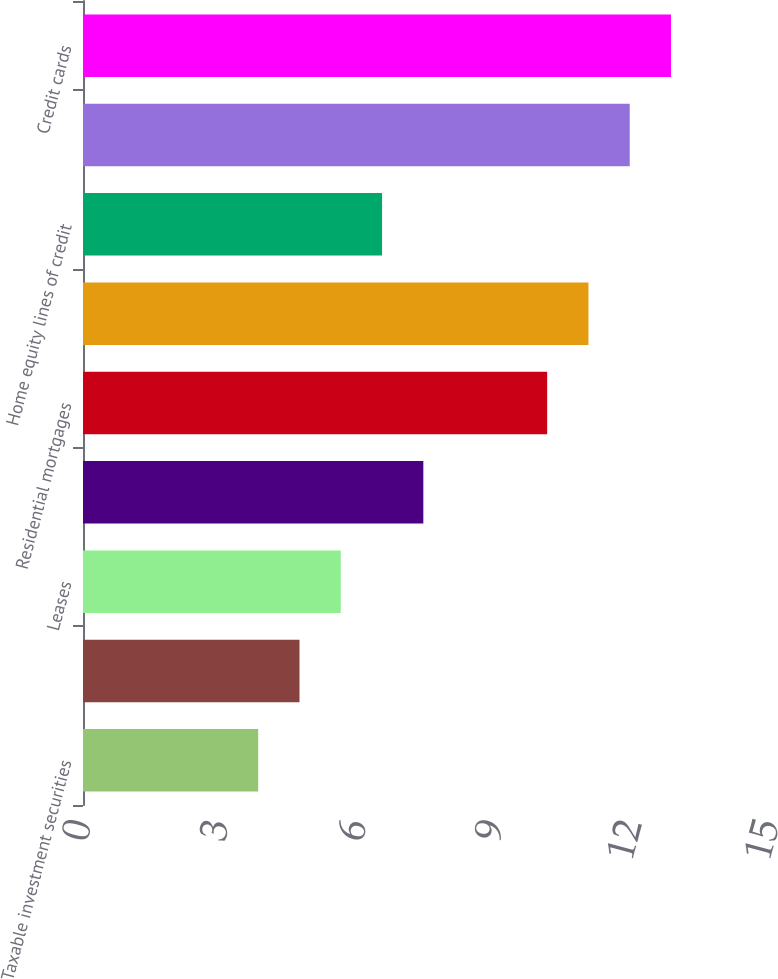<chart> <loc_0><loc_0><loc_500><loc_500><bar_chart><fcel>Taxable investment securities<fcel>Total investment securities<fcel>Leases<fcel>Total commercial loans and<fcel>Residential mortgages<fcel>Home equity loans<fcel>Home equity lines of credit<fcel>Home equity loans serviced by<fcel>Credit cards<nl><fcel>3.82<fcel>4.72<fcel>5.62<fcel>7.42<fcel>10.12<fcel>11.02<fcel>6.52<fcel>11.92<fcel>12.82<nl></chart> 